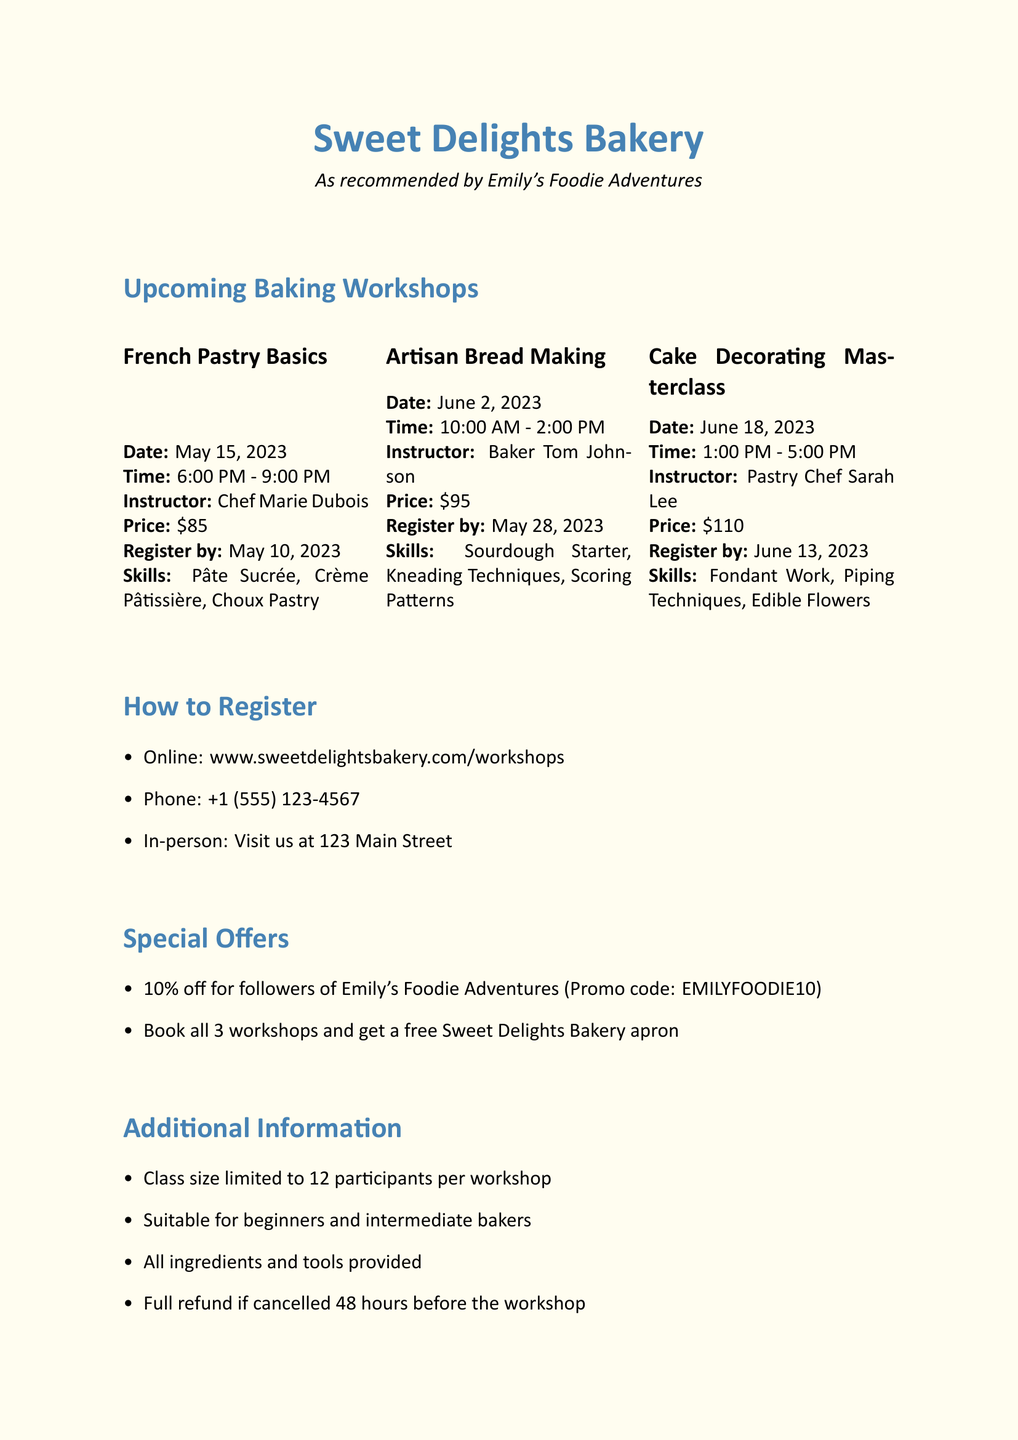what is the price of the Cake Decorating Masterclass? The price of the workshop is listed in the document under the "Price" section for that class.
Answer: $110 who is the instructor for the French Pastry Basics workshop? The instructor's name is mentioned in the details for the French Pastry Basics workshop.
Answer: Chef Marie Dubois when is the registration deadline for the Artisan Bread Making workshop? The registration deadline is specified in the workshop details for Artisan Bread Making.
Answer: May 28, 2023 what skills are covered in the French Pastry Basics workshop? The skills covered are listed in the skills section for the French Pastry Basics workshop.
Answer: Pâte Sucrée, Crème Pâtissière, Choux Pastry how many participants are allowed in each workshop? The class size limit is indicated in the additional information section of the document.
Answer: 12 participants what is the promo code for the discount? The promo code is provided in the special offers section of the document.
Answer: EMILYFOODIE10 which social media platform has the handle @sweetdelightsbakery? The social media handles are listed at the end of the document, specifying the platform corresponding to that handle.
Answer: Instagram when will the Artisan Bread Making workshop take place? The date for the Artisan Bread Making workshop is mentioned clearly in the workshop details.
Answer: June 2, 2023 